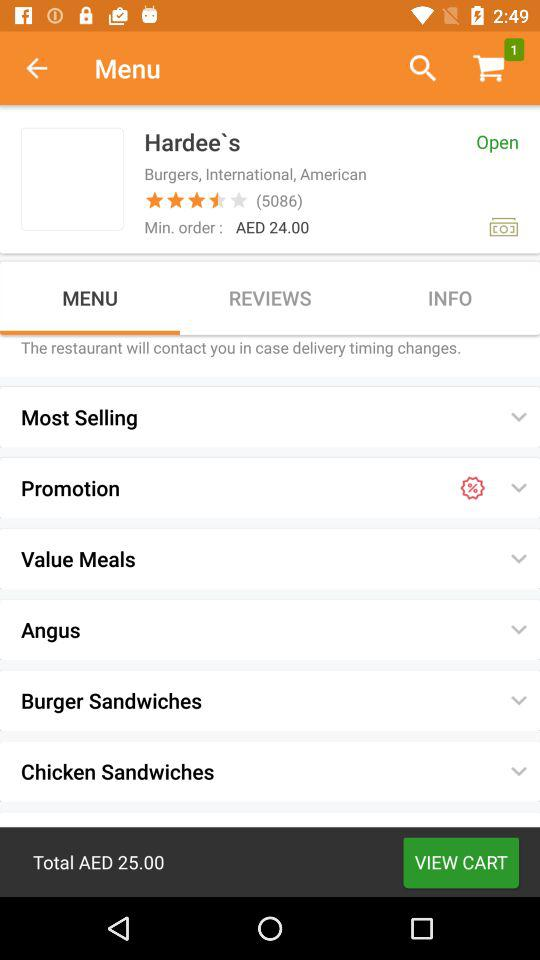How many items are in the cart? The item in the cart is 1. 